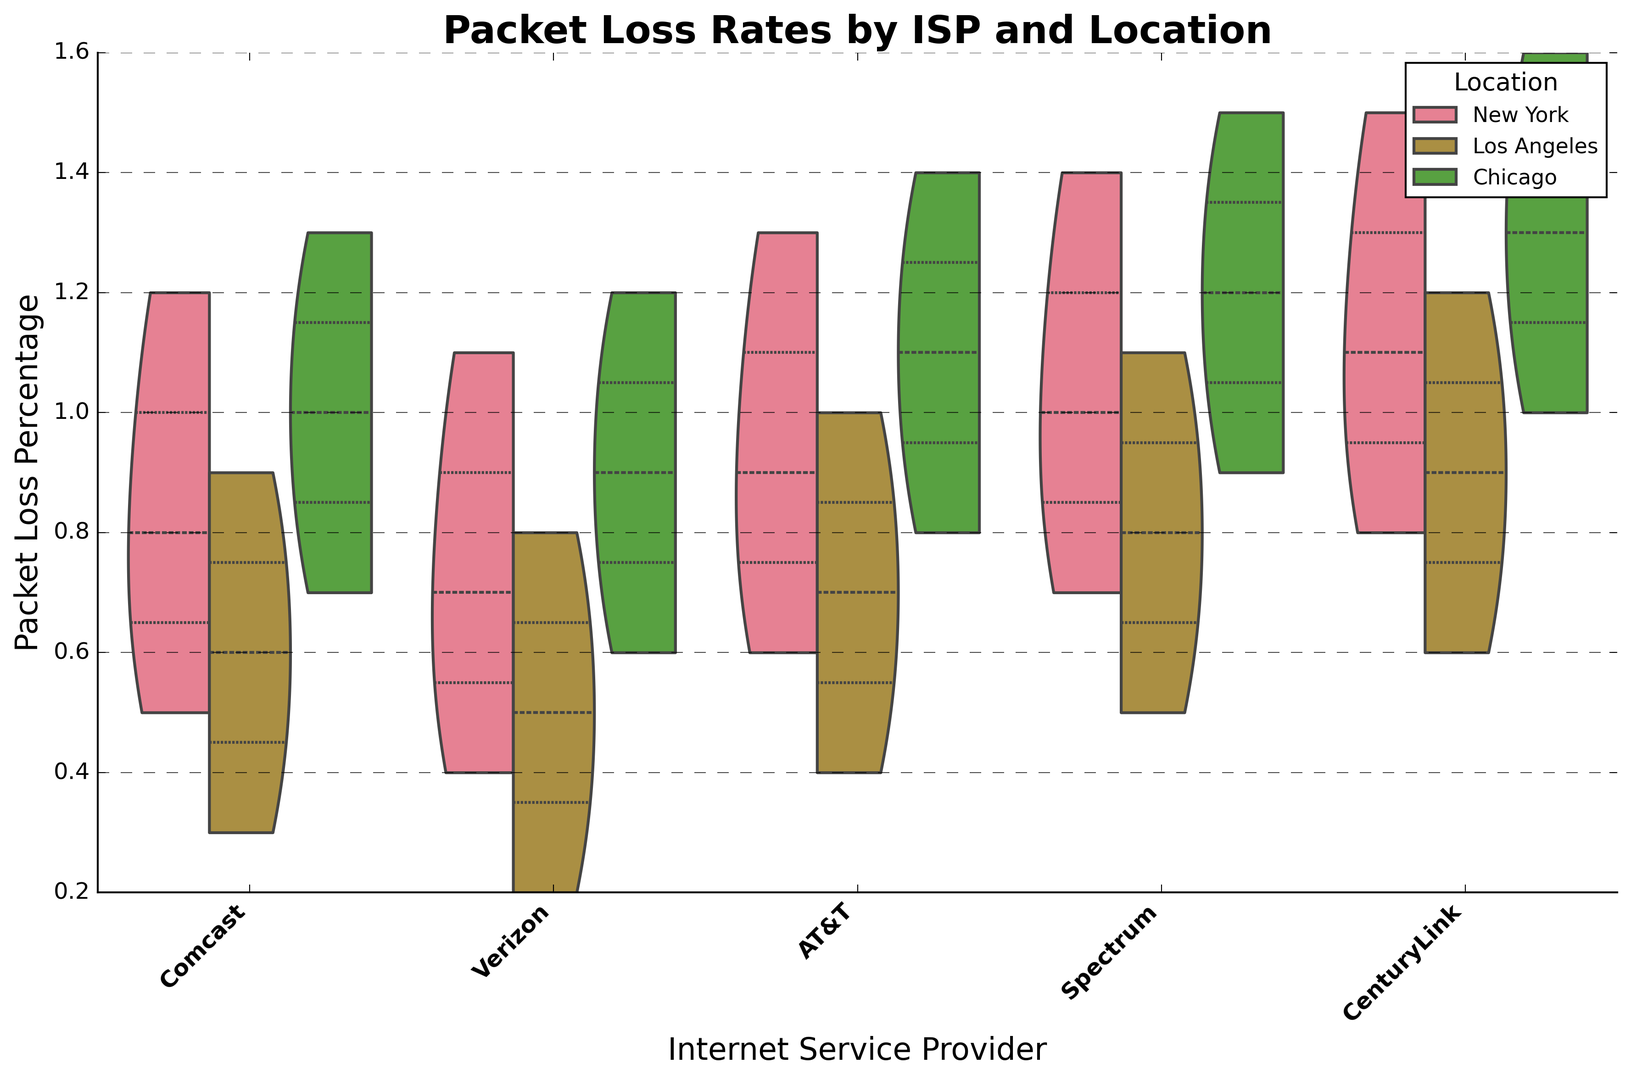Which ISP has the lowest median packet loss percentage? By examining the figure, we can observe the midpoint of each ISP's violin plot. The midpoint (median) of the violin for Verizon is consistently at a lower percentage compared to other ISPs.
Answer: Verizon How does the packet loss rate variability for Spectrum in New York compare to Los Angeles? The width of the violins represents the variability. For Spectrum, the violin plot in New York is wider than in Los Angeles, indicating higher variability in packet loss rates.
Answer: Higher in New York Which city generally experiences the highest packet loss rates across all ISPs? By examining the general height and spread of the violins, Chicago seems to have the highest packet loss rates as the top ends of the violins for Chicago are notably higher.
Answer: Chicago Is the packet loss rate more consistent for AT&T or CenturyLink in New York? The consistency of packet loss rates can be observed by the width of the violin plots. In New York, AT&T shows a narrower violin compared to CenturyLink, indicating more consistent packet loss rates.
Answer: AT&T Which ISP has the widest range of packet loss rates in Los Angeles? By comparing the height of the violin plots in Los Angeles, Spectrum has the widest range as its violin plot extends from a low to a high packet loss rate more than any other ISP.
Answer: Spectrum Out of Comcast, AT&T, and CenturyLink, which has the highest average packet loss rate in Chicago? Averaging the values visually, CenturyLink's violin plot appears to have a higher central tendency than both Comcast and AT&T in Chicago.
Answer: CenturyLink Compare the packet loss variability between Verizon and Spectrum across all locations. Spectrum’s violin plot widths are generally wider than Verizon’s across all locations, indicating that Spectrum has higher packet loss variability.
Answer: Spectrum Which ISP and location combination shows the narrowest distribution of packet loss rates? Looking at the width of the violin plots, Verizon in Los Angeles shows the narrowest distribution, signifying the smallest variability in packet loss rates.
Answer: Verizon in Los Angeles Would a gamer in New York generally have a better packet loss experience with Comcast or Verizon? By comparing the medians and spreads in New York, Verizon exhibits consistently lower and narrower packet loss rates compared to Comcast.
Answer: Verizon Which location for Spectrum has the highest median packet loss rate? By examining the medians of the violin plots for Spectrum, Chicago’s median packet loss rate appears to be the highest.
Answer: Chicago 